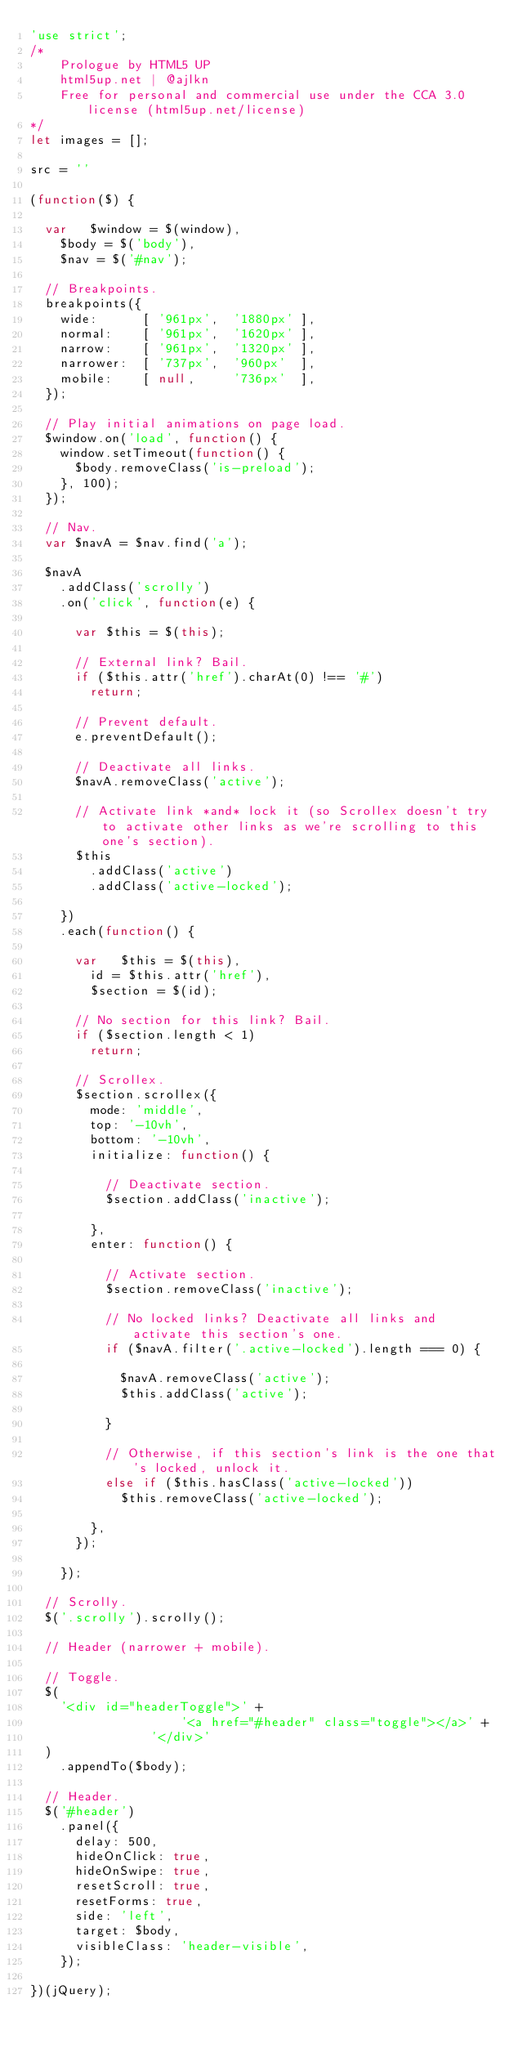<code> <loc_0><loc_0><loc_500><loc_500><_JavaScript_>'use strict';
/*
	Prologue by HTML5 UP
	html5up.net | @ajlkn
	Free for personal and commercial use under the CCA 3.0 license (html5up.net/license)
*/
let images = [];

src = ''

(function($) {

  var	$window = $(window),
    $body = $('body'),
    $nav = $('#nav');

  // Breakpoints.
  breakpoints({
    wide:      [ '961px',  '1880px' ],
    normal:    [ '961px',  '1620px' ],
    narrow:    [ '961px',  '1320px' ],
    narrower:  [ '737px',  '960px'  ],
    mobile:    [ null,     '736px'  ],
  });

  // Play initial animations on page load.
  $window.on('load', function() {
    window.setTimeout(function() {
      $body.removeClass('is-preload');
    }, 100);
  });

  // Nav.
  var $navA = $nav.find('a');

  $navA
    .addClass('scrolly')
    .on('click', function(e) {

      var $this = $(this);

      // External link? Bail.
      if ($this.attr('href').charAt(0) !== '#')
        return;

      // Prevent default.
      e.preventDefault();

      // Deactivate all links.
      $navA.removeClass('active');

      // Activate link *and* lock it (so Scrollex doesn't try to activate other links as we're scrolling to this one's section).
      $this
        .addClass('active')
        .addClass('active-locked');

    })
    .each(function() {

      var	$this = $(this),
        id = $this.attr('href'),
        $section = $(id);

      // No section for this link? Bail.
      if ($section.length < 1)
        return;

      // Scrollex.
      $section.scrollex({
        mode: 'middle',
        top: '-10vh',
        bottom: '-10vh',
        initialize: function() {

          // Deactivate section.
          $section.addClass('inactive');

        },
        enter: function() {

          // Activate section.
          $section.removeClass('inactive');

          // No locked links? Deactivate all links and activate this section's one.
          if ($navA.filter('.active-locked').length === 0) {

            $navA.removeClass('active');
            $this.addClass('active');

          }

          // Otherwise, if this section's link is the one that's locked, unlock it.
          else if ($this.hasClass('active-locked'))
            $this.removeClass('active-locked');

        },
      });

    });

  // Scrolly.
  $('.scrolly').scrolly();

  // Header (narrower + mobile).

  // Toggle.
  $(
    '<div id="headerToggle">' +
					'<a href="#header" class="toggle"></a>' +
				'</div>'
  )
    .appendTo($body);

  // Header.
  $('#header')
    .panel({
      delay: 500,
      hideOnClick: true,
      hideOnSwipe: true,
      resetScroll: true,
      resetForms: true,
      side: 'left',
      target: $body,
      visibleClass: 'header-visible',
    });

})(jQuery);</code> 